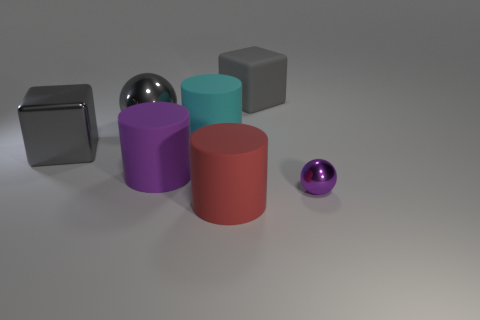Add 1 cyan rubber things. How many objects exist? 8 Subtract all spheres. How many objects are left? 5 Subtract all cyan cylinders. Subtract all green things. How many objects are left? 6 Add 7 gray shiny blocks. How many gray shiny blocks are left? 8 Add 6 small green metal balls. How many small green metal balls exist? 6 Subtract 0 blue balls. How many objects are left? 7 